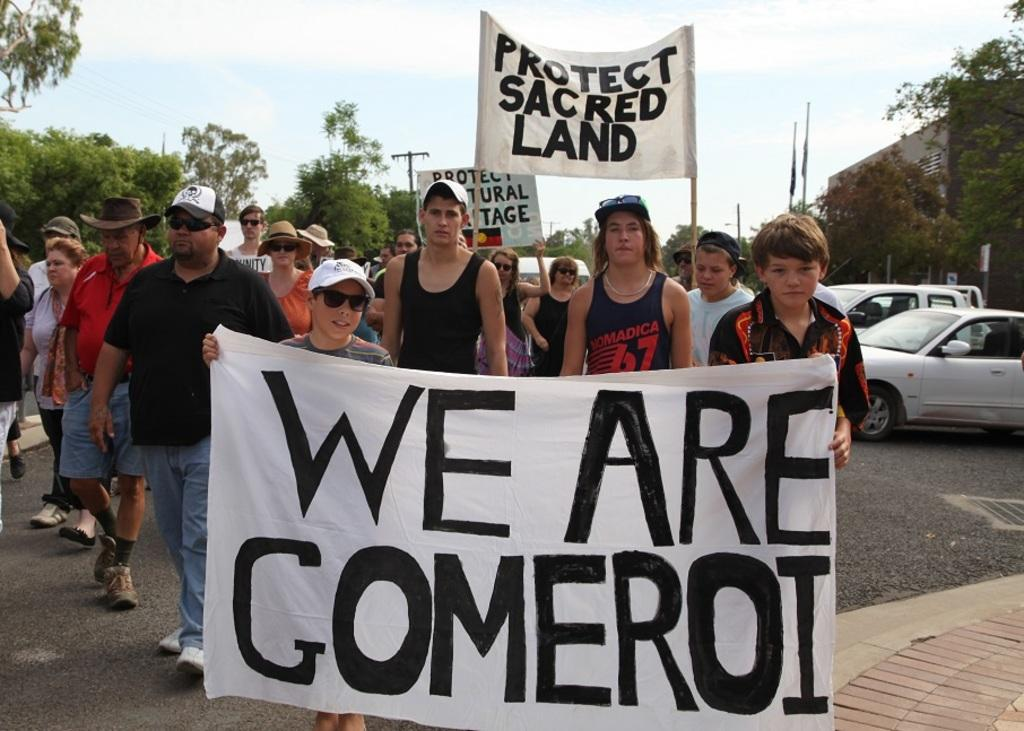What is happening in the image involving a large group of people? There are many people protesting in the image. Where is the protest taking place? The protest is taking place on the road. What else can be seen on the right side of the image? There are cars on the right side of the image. What is present in the middle of the image? There are trees in the middle of the image. Can you see a cow jumping over the trees in the image? There is no cow or jumping activity present in the image; it features a protest on the road with trees in the middle. 